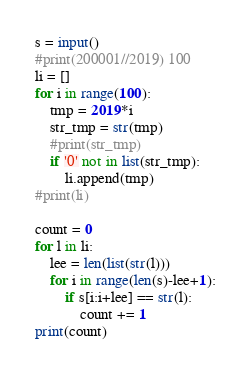<code> <loc_0><loc_0><loc_500><loc_500><_Python_>s = input()
#print(200001//2019) 100
li = []
for i in range(100):
    tmp = 2019*i
    str_tmp = str(tmp)
    #print(str_tmp)
    if '0' not in list(str_tmp):
        li.append(tmp)
#print(li)

count = 0
for l in li:
    lee = len(list(str(l)))
    for i in range(len(s)-lee+1):
        if s[i:i+lee] == str(l):
            count += 1
print(count)</code> 